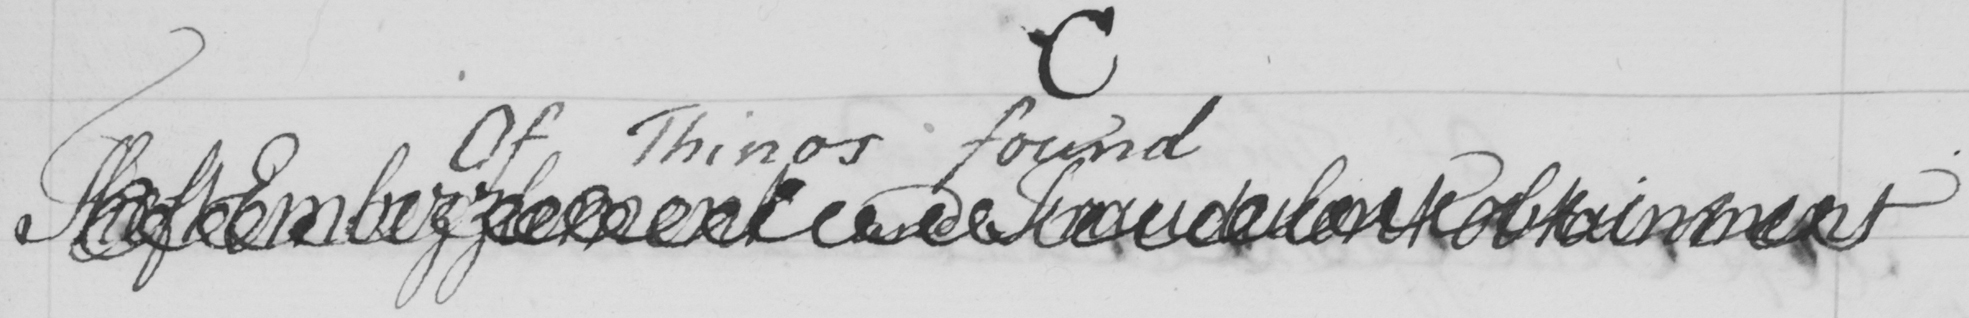Please transcribe the handwritten text in this image. The Embezzelment and Fradulent Punishment 